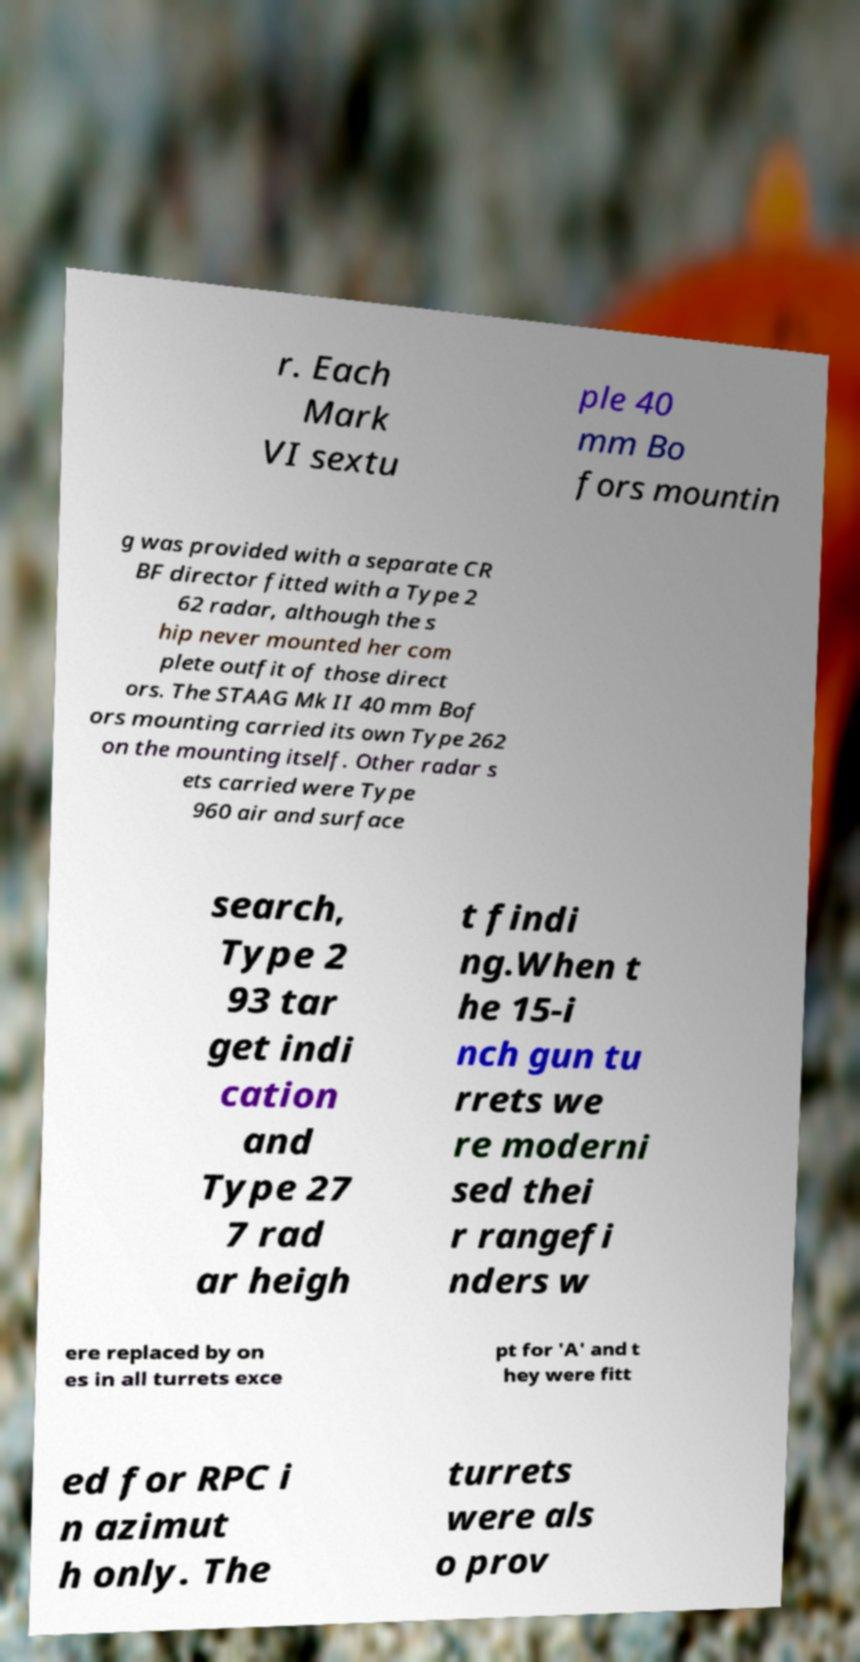Can you read and provide the text displayed in the image?This photo seems to have some interesting text. Can you extract and type it out for me? r. Each Mark VI sextu ple 40 mm Bo fors mountin g was provided with a separate CR BF director fitted with a Type 2 62 radar, although the s hip never mounted her com plete outfit of those direct ors. The STAAG Mk II 40 mm Bof ors mounting carried its own Type 262 on the mounting itself. Other radar s ets carried were Type 960 air and surface search, Type 2 93 tar get indi cation and Type 27 7 rad ar heigh t findi ng.When t he 15-i nch gun tu rrets we re moderni sed thei r rangefi nders w ere replaced by on es in all turrets exce pt for 'A' and t hey were fitt ed for RPC i n azimut h only. The turrets were als o prov 